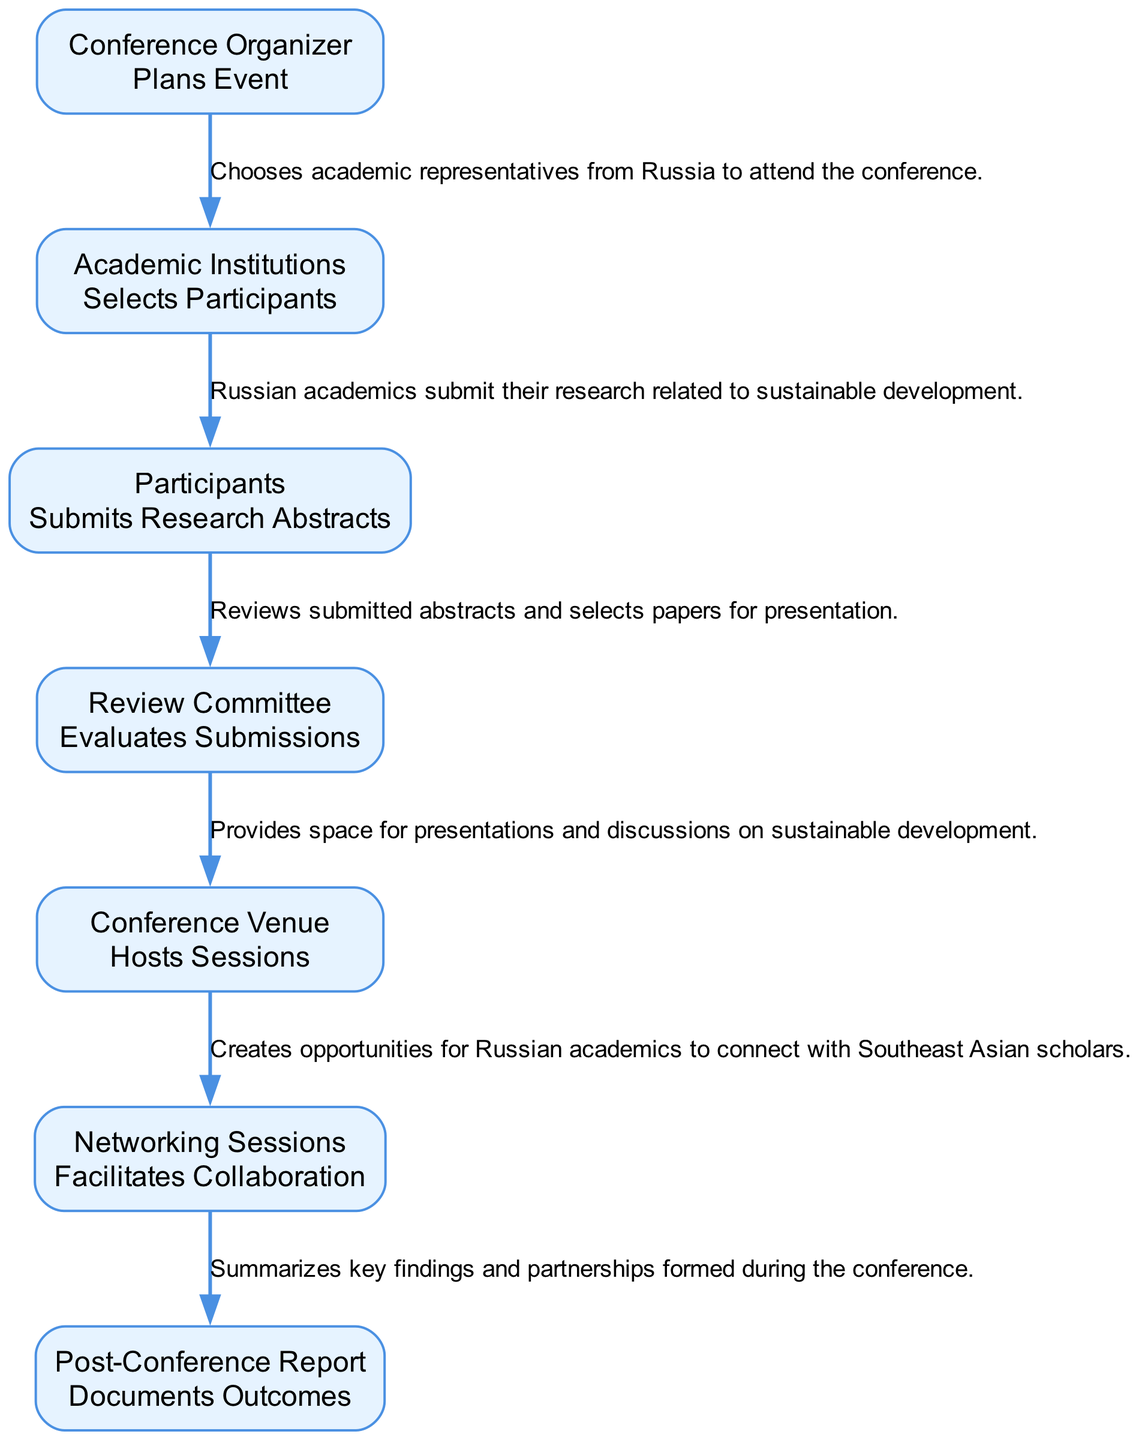What is the first action in the sequence diagram? The first action in the sequence diagram is "Plans Event," which is associated with the entity "Conference Organizer." This is the initial step where the organizer identifies topics and invites speakers.
Answer: Plans Event How many entities are involved in the workflow? By reviewing the elements in the diagram, we can count that there are 7 distinct entities involved in the workflow: Conference Organizer, Academic Institutions, Participants, Review Committee, Conference Venue, Networking Sessions, and Post-Conference Report.
Answer: 7 What action follows "Selects Participants"? The action that follows "Selects Participants" is "Submits Research Abstracts." This indicates that after academic institutions choose their representatives, these representatives submit their research findings related to sustainable development.
Answer: Submits Research Abstracts Which entity hosts the sessions? The entity responsible for hosting the sessions is the "Conference Venue." Its role is to provide the physical space for presentations and discussions during the conference.
Answer: Conference Venue What is the relationship between "Participants" and "Review Committee"? The relationship is that "Participants" submit their research abstracts, which are then evaluated by the "Review Committee." This shows a direct flow of information from the participants to the committee for selection.
Answer: Submits Research Abstracts, Evaluates Submissions How does the "Networking Sessions" contribute to the conference? The "Networking Sessions" facilitate collaboration by creating opportunities for Russian academics to connect with their Southeast Asian counterparts. This helps to establish partnerships and share knowledge, enhancing the development project's goals.
Answer: Facilitates Collaboration What is documented in the "Post-Conference Report"? The "Post-Conference Report" documents the outcomes of the conference, summarizing key findings and partnerships formed. This encapsulates the essence of what was achieved during the event.
Answer: Documents Outcomes What is the last action in the sequence diagram? The last action in the sequence diagram is "Documents Outcomes." This concludes the workflow by summarizing the results and collaborations that emerged from the conference discussions.
Answer: Documents Outcomes 